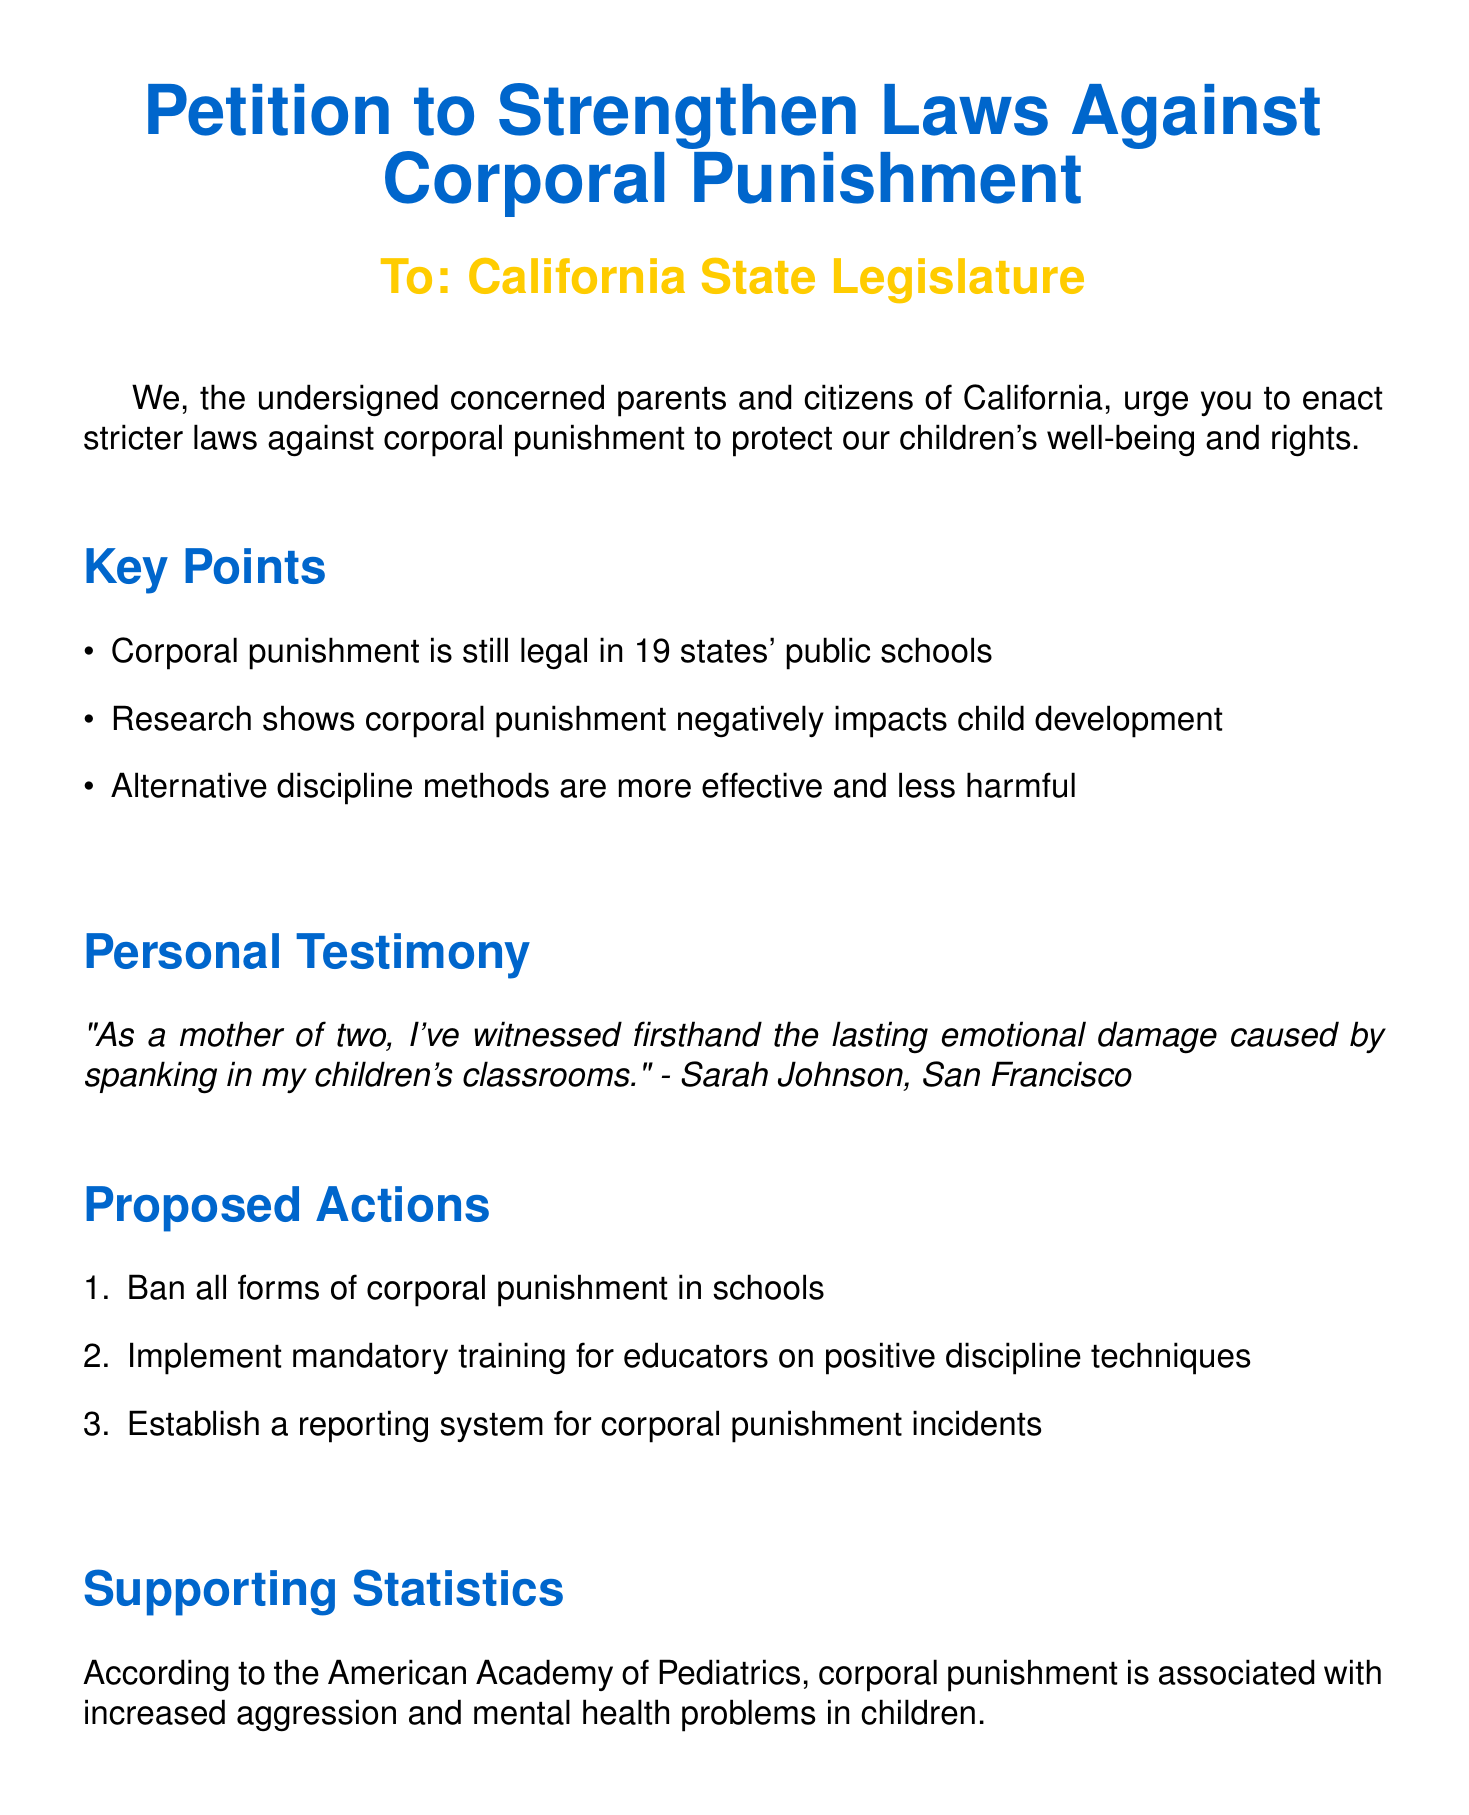What is the title of the petition? The title summarizes the main purpose of the document, which is to advocate for stricter laws against corporal punishment.
Answer: Petition to Strengthen Laws Against Corporal Punishment Who is the petition addressed to? The document specifies the intended recipients of the petition.
Answer: California State Legislature How many states still allow corporal punishment in public schools? The document provides a specific number representing the states where corporal punishment is legal.
Answer: 19 Who provided a personal testimony in the document? This question seeks the name of the individual who shared their experience regarding corporal punishment.
Answer: Sarah Johnson What is one proposed action mentioned in the petition? The document lists several proposed actions to mitigate corporal punishment.
Answer: Ban all forms of corporal punishment in schools What association is referenced for supporting statistics? The document includes an organization that provided statistics related to corporal punishment.
Answer: American Academy of Pediatrics What city is Michael Chen from? The document lists the names and corresponding cities of the signatories.
Answer: Los Angeles What is the email contact for further information? The document includes a specific contact method for inquiries related to the petition.
Answer: info@pacp.org 